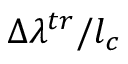<formula> <loc_0><loc_0><loc_500><loc_500>\Delta \lambda ^ { t r } / l _ { c }</formula> 